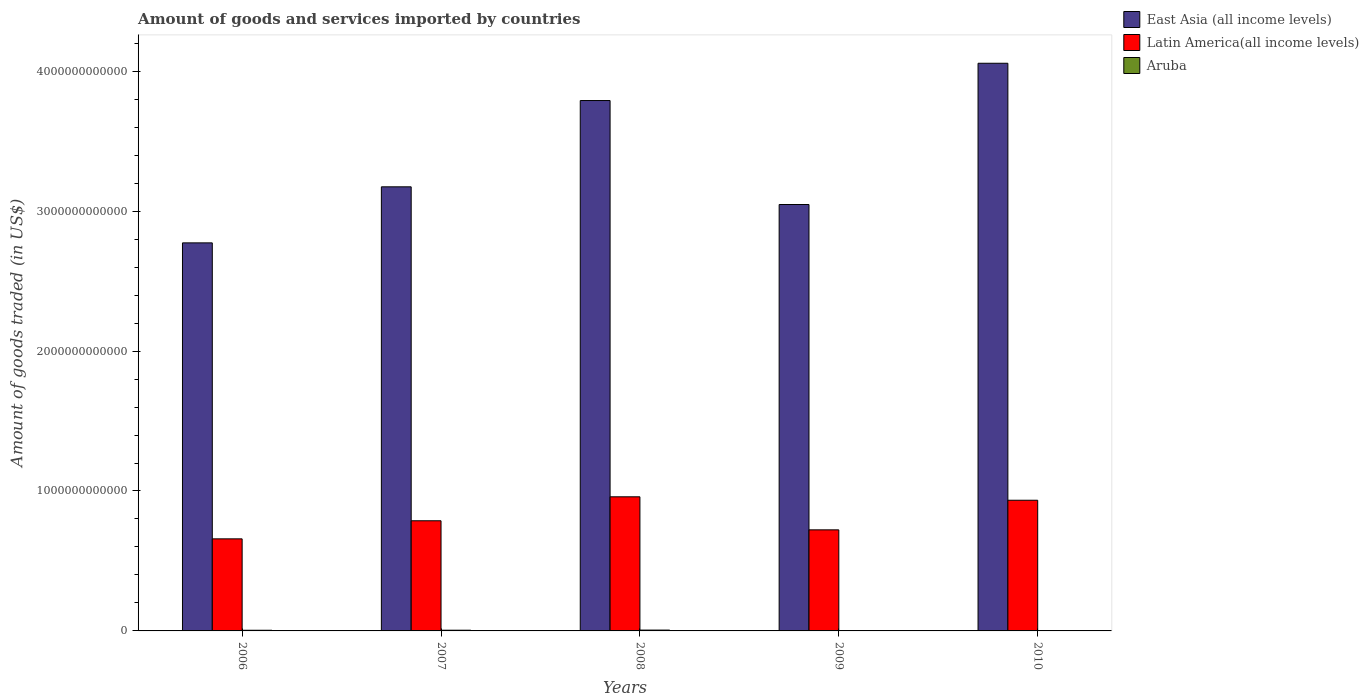How many different coloured bars are there?
Keep it short and to the point. 3. How many groups of bars are there?
Provide a succinct answer. 5. Are the number of bars on each tick of the X-axis equal?
Keep it short and to the point. Yes. How many bars are there on the 1st tick from the left?
Your answer should be compact. 3. How many bars are there on the 2nd tick from the right?
Provide a short and direct response. 3. In how many cases, is the number of bars for a given year not equal to the number of legend labels?
Your response must be concise. 0. What is the total amount of goods and services imported in Latin America(all income levels) in 2007?
Ensure brevity in your answer.  7.87e+11. Across all years, what is the maximum total amount of goods and services imported in East Asia (all income levels)?
Make the answer very short. 4.06e+12. Across all years, what is the minimum total amount of goods and services imported in East Asia (all income levels)?
Your response must be concise. 2.77e+12. In which year was the total amount of goods and services imported in Aruba maximum?
Provide a succinct answer. 2008. What is the total total amount of goods and services imported in Aruba in the graph?
Keep it short and to the point. 1.97e+1. What is the difference between the total amount of goods and services imported in Latin America(all income levels) in 2006 and that in 2009?
Offer a very short reply. -6.43e+1. What is the difference between the total amount of goods and services imported in Aruba in 2009 and the total amount of goods and services imported in East Asia (all income levels) in 2006?
Your response must be concise. -2.77e+12. What is the average total amount of goods and services imported in Aruba per year?
Offer a very short reply. 3.94e+09. In the year 2008, what is the difference between the total amount of goods and services imported in East Asia (all income levels) and total amount of goods and services imported in Latin America(all income levels)?
Ensure brevity in your answer.  2.83e+12. In how many years, is the total amount of goods and services imported in Aruba greater than 2800000000000 US$?
Provide a short and direct response. 0. What is the ratio of the total amount of goods and services imported in East Asia (all income levels) in 2007 to that in 2009?
Offer a terse response. 1.04. Is the total amount of goods and services imported in Latin America(all income levels) in 2006 less than that in 2007?
Provide a short and direct response. Yes. Is the difference between the total amount of goods and services imported in East Asia (all income levels) in 2007 and 2010 greater than the difference between the total amount of goods and services imported in Latin America(all income levels) in 2007 and 2010?
Ensure brevity in your answer.  No. What is the difference between the highest and the second highest total amount of goods and services imported in Latin America(all income levels)?
Make the answer very short. 2.45e+1. What is the difference between the highest and the lowest total amount of goods and services imported in East Asia (all income levels)?
Provide a succinct answer. 1.28e+12. Is the sum of the total amount of goods and services imported in Aruba in 2006 and 2008 greater than the maximum total amount of goods and services imported in East Asia (all income levels) across all years?
Make the answer very short. No. What does the 2nd bar from the left in 2007 represents?
Your answer should be compact. Latin America(all income levels). What does the 1st bar from the right in 2008 represents?
Provide a short and direct response. Aruba. Are all the bars in the graph horizontal?
Provide a succinct answer. No. How many years are there in the graph?
Provide a succinct answer. 5. What is the difference between two consecutive major ticks on the Y-axis?
Provide a succinct answer. 1.00e+12. Does the graph contain grids?
Make the answer very short. No. How many legend labels are there?
Your answer should be very brief. 3. How are the legend labels stacked?
Ensure brevity in your answer.  Vertical. What is the title of the graph?
Offer a terse response. Amount of goods and services imported by countries. What is the label or title of the X-axis?
Your answer should be compact. Years. What is the label or title of the Y-axis?
Provide a succinct answer. Amount of goods traded (in US$). What is the Amount of goods traded (in US$) of East Asia (all income levels) in 2006?
Ensure brevity in your answer.  2.77e+12. What is the Amount of goods traded (in US$) in Latin America(all income levels) in 2006?
Offer a very short reply. 6.58e+11. What is the Amount of goods traded (in US$) of Aruba in 2006?
Provide a succinct answer. 4.72e+09. What is the Amount of goods traded (in US$) in East Asia (all income levels) in 2007?
Make the answer very short. 3.17e+12. What is the Amount of goods traded (in US$) in Latin America(all income levels) in 2007?
Offer a terse response. 7.87e+11. What is the Amount of goods traded (in US$) in Aruba in 2007?
Your answer should be compact. 5.13e+09. What is the Amount of goods traded (in US$) of East Asia (all income levels) in 2008?
Keep it short and to the point. 3.79e+12. What is the Amount of goods traded (in US$) of Latin America(all income levels) in 2008?
Keep it short and to the point. 9.58e+11. What is the Amount of goods traded (in US$) of Aruba in 2008?
Offer a terse response. 6.02e+09. What is the Amount of goods traded (in US$) of East Asia (all income levels) in 2009?
Ensure brevity in your answer.  3.05e+12. What is the Amount of goods traded (in US$) of Latin America(all income levels) in 2009?
Keep it short and to the point. 7.22e+11. What is the Amount of goods traded (in US$) in Aruba in 2009?
Make the answer very short. 2.45e+09. What is the Amount of goods traded (in US$) of East Asia (all income levels) in 2010?
Ensure brevity in your answer.  4.06e+12. What is the Amount of goods traded (in US$) of Latin America(all income levels) in 2010?
Provide a short and direct response. 9.34e+11. What is the Amount of goods traded (in US$) of Aruba in 2010?
Provide a short and direct response. 1.39e+09. Across all years, what is the maximum Amount of goods traded (in US$) in East Asia (all income levels)?
Ensure brevity in your answer.  4.06e+12. Across all years, what is the maximum Amount of goods traded (in US$) of Latin America(all income levels)?
Give a very brief answer. 9.58e+11. Across all years, what is the maximum Amount of goods traded (in US$) in Aruba?
Offer a very short reply. 6.02e+09. Across all years, what is the minimum Amount of goods traded (in US$) in East Asia (all income levels)?
Keep it short and to the point. 2.77e+12. Across all years, what is the minimum Amount of goods traded (in US$) of Latin America(all income levels)?
Keep it short and to the point. 6.58e+11. Across all years, what is the minimum Amount of goods traded (in US$) of Aruba?
Offer a terse response. 1.39e+09. What is the total Amount of goods traded (in US$) in East Asia (all income levels) in the graph?
Ensure brevity in your answer.  1.68e+13. What is the total Amount of goods traded (in US$) of Latin America(all income levels) in the graph?
Keep it short and to the point. 4.06e+12. What is the total Amount of goods traded (in US$) in Aruba in the graph?
Provide a short and direct response. 1.97e+1. What is the difference between the Amount of goods traded (in US$) of East Asia (all income levels) in 2006 and that in 2007?
Provide a short and direct response. -4.01e+11. What is the difference between the Amount of goods traded (in US$) of Latin America(all income levels) in 2006 and that in 2007?
Your answer should be compact. -1.29e+11. What is the difference between the Amount of goods traded (in US$) in Aruba in 2006 and that in 2007?
Provide a succinct answer. -4.02e+08. What is the difference between the Amount of goods traded (in US$) of East Asia (all income levels) in 2006 and that in 2008?
Your answer should be very brief. -1.02e+12. What is the difference between the Amount of goods traded (in US$) of Latin America(all income levels) in 2006 and that in 2008?
Keep it short and to the point. -3.00e+11. What is the difference between the Amount of goods traded (in US$) of Aruba in 2006 and that in 2008?
Your answer should be very brief. -1.29e+09. What is the difference between the Amount of goods traded (in US$) of East Asia (all income levels) in 2006 and that in 2009?
Provide a short and direct response. -2.74e+11. What is the difference between the Amount of goods traded (in US$) in Latin America(all income levels) in 2006 and that in 2009?
Provide a succinct answer. -6.43e+1. What is the difference between the Amount of goods traded (in US$) in Aruba in 2006 and that in 2009?
Offer a terse response. 2.27e+09. What is the difference between the Amount of goods traded (in US$) of East Asia (all income levels) in 2006 and that in 2010?
Keep it short and to the point. -1.28e+12. What is the difference between the Amount of goods traded (in US$) in Latin America(all income levels) in 2006 and that in 2010?
Keep it short and to the point. -2.76e+11. What is the difference between the Amount of goods traded (in US$) of Aruba in 2006 and that in 2010?
Make the answer very short. 3.33e+09. What is the difference between the Amount of goods traded (in US$) of East Asia (all income levels) in 2007 and that in 2008?
Keep it short and to the point. -6.17e+11. What is the difference between the Amount of goods traded (in US$) of Latin America(all income levels) in 2007 and that in 2008?
Offer a very short reply. -1.71e+11. What is the difference between the Amount of goods traded (in US$) in Aruba in 2007 and that in 2008?
Your answer should be compact. -8.92e+08. What is the difference between the Amount of goods traded (in US$) in East Asia (all income levels) in 2007 and that in 2009?
Your answer should be very brief. 1.26e+11. What is the difference between the Amount of goods traded (in US$) in Latin America(all income levels) in 2007 and that in 2009?
Your response must be concise. 6.49e+1. What is the difference between the Amount of goods traded (in US$) of Aruba in 2007 and that in 2009?
Your answer should be very brief. 2.67e+09. What is the difference between the Amount of goods traded (in US$) of East Asia (all income levels) in 2007 and that in 2010?
Provide a short and direct response. -8.83e+11. What is the difference between the Amount of goods traded (in US$) in Latin America(all income levels) in 2007 and that in 2010?
Your answer should be compact. -1.47e+11. What is the difference between the Amount of goods traded (in US$) in Aruba in 2007 and that in 2010?
Give a very brief answer. 3.73e+09. What is the difference between the Amount of goods traded (in US$) of East Asia (all income levels) in 2008 and that in 2009?
Offer a very short reply. 7.43e+11. What is the difference between the Amount of goods traded (in US$) of Latin America(all income levels) in 2008 and that in 2009?
Make the answer very short. 2.36e+11. What is the difference between the Amount of goods traded (in US$) in Aruba in 2008 and that in 2009?
Offer a terse response. 3.56e+09. What is the difference between the Amount of goods traded (in US$) of East Asia (all income levels) in 2008 and that in 2010?
Offer a very short reply. -2.66e+11. What is the difference between the Amount of goods traded (in US$) of Latin America(all income levels) in 2008 and that in 2010?
Ensure brevity in your answer.  2.45e+1. What is the difference between the Amount of goods traded (in US$) in Aruba in 2008 and that in 2010?
Ensure brevity in your answer.  4.62e+09. What is the difference between the Amount of goods traded (in US$) of East Asia (all income levels) in 2009 and that in 2010?
Ensure brevity in your answer.  -1.01e+12. What is the difference between the Amount of goods traded (in US$) of Latin America(all income levels) in 2009 and that in 2010?
Provide a succinct answer. -2.12e+11. What is the difference between the Amount of goods traded (in US$) of Aruba in 2009 and that in 2010?
Provide a short and direct response. 1.06e+09. What is the difference between the Amount of goods traded (in US$) of East Asia (all income levels) in 2006 and the Amount of goods traded (in US$) of Latin America(all income levels) in 2007?
Your response must be concise. 1.99e+12. What is the difference between the Amount of goods traded (in US$) of East Asia (all income levels) in 2006 and the Amount of goods traded (in US$) of Aruba in 2007?
Your answer should be very brief. 2.77e+12. What is the difference between the Amount of goods traded (in US$) of Latin America(all income levels) in 2006 and the Amount of goods traded (in US$) of Aruba in 2007?
Make the answer very short. 6.53e+11. What is the difference between the Amount of goods traded (in US$) of East Asia (all income levels) in 2006 and the Amount of goods traded (in US$) of Latin America(all income levels) in 2008?
Offer a terse response. 1.81e+12. What is the difference between the Amount of goods traded (in US$) of East Asia (all income levels) in 2006 and the Amount of goods traded (in US$) of Aruba in 2008?
Keep it short and to the point. 2.77e+12. What is the difference between the Amount of goods traded (in US$) of Latin America(all income levels) in 2006 and the Amount of goods traded (in US$) of Aruba in 2008?
Provide a short and direct response. 6.52e+11. What is the difference between the Amount of goods traded (in US$) of East Asia (all income levels) in 2006 and the Amount of goods traded (in US$) of Latin America(all income levels) in 2009?
Your response must be concise. 2.05e+12. What is the difference between the Amount of goods traded (in US$) of East Asia (all income levels) in 2006 and the Amount of goods traded (in US$) of Aruba in 2009?
Provide a succinct answer. 2.77e+12. What is the difference between the Amount of goods traded (in US$) in Latin America(all income levels) in 2006 and the Amount of goods traded (in US$) in Aruba in 2009?
Your answer should be compact. 6.56e+11. What is the difference between the Amount of goods traded (in US$) of East Asia (all income levels) in 2006 and the Amount of goods traded (in US$) of Latin America(all income levels) in 2010?
Offer a terse response. 1.84e+12. What is the difference between the Amount of goods traded (in US$) of East Asia (all income levels) in 2006 and the Amount of goods traded (in US$) of Aruba in 2010?
Offer a very short reply. 2.77e+12. What is the difference between the Amount of goods traded (in US$) of Latin America(all income levels) in 2006 and the Amount of goods traded (in US$) of Aruba in 2010?
Offer a very short reply. 6.57e+11. What is the difference between the Amount of goods traded (in US$) in East Asia (all income levels) in 2007 and the Amount of goods traded (in US$) in Latin America(all income levels) in 2008?
Your response must be concise. 2.22e+12. What is the difference between the Amount of goods traded (in US$) in East Asia (all income levels) in 2007 and the Amount of goods traded (in US$) in Aruba in 2008?
Offer a very short reply. 3.17e+12. What is the difference between the Amount of goods traded (in US$) in Latin America(all income levels) in 2007 and the Amount of goods traded (in US$) in Aruba in 2008?
Your response must be concise. 7.81e+11. What is the difference between the Amount of goods traded (in US$) of East Asia (all income levels) in 2007 and the Amount of goods traded (in US$) of Latin America(all income levels) in 2009?
Provide a succinct answer. 2.45e+12. What is the difference between the Amount of goods traded (in US$) of East Asia (all income levels) in 2007 and the Amount of goods traded (in US$) of Aruba in 2009?
Provide a short and direct response. 3.17e+12. What is the difference between the Amount of goods traded (in US$) of Latin America(all income levels) in 2007 and the Amount of goods traded (in US$) of Aruba in 2009?
Your answer should be compact. 7.85e+11. What is the difference between the Amount of goods traded (in US$) of East Asia (all income levels) in 2007 and the Amount of goods traded (in US$) of Latin America(all income levels) in 2010?
Keep it short and to the point. 2.24e+12. What is the difference between the Amount of goods traded (in US$) of East Asia (all income levels) in 2007 and the Amount of goods traded (in US$) of Aruba in 2010?
Make the answer very short. 3.17e+12. What is the difference between the Amount of goods traded (in US$) of Latin America(all income levels) in 2007 and the Amount of goods traded (in US$) of Aruba in 2010?
Your answer should be very brief. 7.86e+11. What is the difference between the Amount of goods traded (in US$) of East Asia (all income levels) in 2008 and the Amount of goods traded (in US$) of Latin America(all income levels) in 2009?
Give a very brief answer. 3.07e+12. What is the difference between the Amount of goods traded (in US$) of East Asia (all income levels) in 2008 and the Amount of goods traded (in US$) of Aruba in 2009?
Keep it short and to the point. 3.79e+12. What is the difference between the Amount of goods traded (in US$) of Latin America(all income levels) in 2008 and the Amount of goods traded (in US$) of Aruba in 2009?
Give a very brief answer. 9.56e+11. What is the difference between the Amount of goods traded (in US$) in East Asia (all income levels) in 2008 and the Amount of goods traded (in US$) in Latin America(all income levels) in 2010?
Make the answer very short. 2.86e+12. What is the difference between the Amount of goods traded (in US$) of East Asia (all income levels) in 2008 and the Amount of goods traded (in US$) of Aruba in 2010?
Keep it short and to the point. 3.79e+12. What is the difference between the Amount of goods traded (in US$) of Latin America(all income levels) in 2008 and the Amount of goods traded (in US$) of Aruba in 2010?
Your response must be concise. 9.57e+11. What is the difference between the Amount of goods traded (in US$) of East Asia (all income levels) in 2009 and the Amount of goods traded (in US$) of Latin America(all income levels) in 2010?
Keep it short and to the point. 2.11e+12. What is the difference between the Amount of goods traded (in US$) of East Asia (all income levels) in 2009 and the Amount of goods traded (in US$) of Aruba in 2010?
Your answer should be compact. 3.05e+12. What is the difference between the Amount of goods traded (in US$) in Latin America(all income levels) in 2009 and the Amount of goods traded (in US$) in Aruba in 2010?
Offer a terse response. 7.21e+11. What is the average Amount of goods traded (in US$) in East Asia (all income levels) per year?
Give a very brief answer. 3.37e+12. What is the average Amount of goods traded (in US$) in Latin America(all income levels) per year?
Your answer should be very brief. 8.12e+11. What is the average Amount of goods traded (in US$) of Aruba per year?
Ensure brevity in your answer.  3.94e+09. In the year 2006, what is the difference between the Amount of goods traded (in US$) of East Asia (all income levels) and Amount of goods traded (in US$) of Latin America(all income levels)?
Keep it short and to the point. 2.12e+12. In the year 2006, what is the difference between the Amount of goods traded (in US$) of East Asia (all income levels) and Amount of goods traded (in US$) of Aruba?
Provide a succinct answer. 2.77e+12. In the year 2006, what is the difference between the Amount of goods traded (in US$) of Latin America(all income levels) and Amount of goods traded (in US$) of Aruba?
Give a very brief answer. 6.53e+11. In the year 2007, what is the difference between the Amount of goods traded (in US$) in East Asia (all income levels) and Amount of goods traded (in US$) in Latin America(all income levels)?
Your answer should be compact. 2.39e+12. In the year 2007, what is the difference between the Amount of goods traded (in US$) of East Asia (all income levels) and Amount of goods traded (in US$) of Aruba?
Provide a short and direct response. 3.17e+12. In the year 2007, what is the difference between the Amount of goods traded (in US$) in Latin America(all income levels) and Amount of goods traded (in US$) in Aruba?
Make the answer very short. 7.82e+11. In the year 2008, what is the difference between the Amount of goods traded (in US$) of East Asia (all income levels) and Amount of goods traded (in US$) of Latin America(all income levels)?
Your answer should be very brief. 2.83e+12. In the year 2008, what is the difference between the Amount of goods traded (in US$) of East Asia (all income levels) and Amount of goods traded (in US$) of Aruba?
Keep it short and to the point. 3.78e+12. In the year 2008, what is the difference between the Amount of goods traded (in US$) in Latin America(all income levels) and Amount of goods traded (in US$) in Aruba?
Your response must be concise. 9.52e+11. In the year 2009, what is the difference between the Amount of goods traded (in US$) in East Asia (all income levels) and Amount of goods traded (in US$) in Latin America(all income levels)?
Your answer should be compact. 2.33e+12. In the year 2009, what is the difference between the Amount of goods traded (in US$) of East Asia (all income levels) and Amount of goods traded (in US$) of Aruba?
Your answer should be very brief. 3.04e+12. In the year 2009, what is the difference between the Amount of goods traded (in US$) in Latin America(all income levels) and Amount of goods traded (in US$) in Aruba?
Provide a short and direct response. 7.20e+11. In the year 2010, what is the difference between the Amount of goods traded (in US$) of East Asia (all income levels) and Amount of goods traded (in US$) of Latin America(all income levels)?
Provide a short and direct response. 3.12e+12. In the year 2010, what is the difference between the Amount of goods traded (in US$) of East Asia (all income levels) and Amount of goods traded (in US$) of Aruba?
Your answer should be compact. 4.06e+12. In the year 2010, what is the difference between the Amount of goods traded (in US$) of Latin America(all income levels) and Amount of goods traded (in US$) of Aruba?
Keep it short and to the point. 9.33e+11. What is the ratio of the Amount of goods traded (in US$) in East Asia (all income levels) in 2006 to that in 2007?
Ensure brevity in your answer.  0.87. What is the ratio of the Amount of goods traded (in US$) in Latin America(all income levels) in 2006 to that in 2007?
Make the answer very short. 0.84. What is the ratio of the Amount of goods traded (in US$) of Aruba in 2006 to that in 2007?
Offer a terse response. 0.92. What is the ratio of the Amount of goods traded (in US$) in East Asia (all income levels) in 2006 to that in 2008?
Your answer should be compact. 0.73. What is the ratio of the Amount of goods traded (in US$) of Latin America(all income levels) in 2006 to that in 2008?
Keep it short and to the point. 0.69. What is the ratio of the Amount of goods traded (in US$) in Aruba in 2006 to that in 2008?
Make the answer very short. 0.79. What is the ratio of the Amount of goods traded (in US$) of East Asia (all income levels) in 2006 to that in 2009?
Keep it short and to the point. 0.91. What is the ratio of the Amount of goods traded (in US$) of Latin America(all income levels) in 2006 to that in 2009?
Your answer should be very brief. 0.91. What is the ratio of the Amount of goods traded (in US$) in Aruba in 2006 to that in 2009?
Provide a short and direct response. 1.93. What is the ratio of the Amount of goods traded (in US$) of East Asia (all income levels) in 2006 to that in 2010?
Ensure brevity in your answer.  0.68. What is the ratio of the Amount of goods traded (in US$) of Latin America(all income levels) in 2006 to that in 2010?
Keep it short and to the point. 0.7. What is the ratio of the Amount of goods traded (in US$) in Aruba in 2006 to that in 2010?
Provide a succinct answer. 3.39. What is the ratio of the Amount of goods traded (in US$) in East Asia (all income levels) in 2007 to that in 2008?
Offer a terse response. 0.84. What is the ratio of the Amount of goods traded (in US$) of Latin America(all income levels) in 2007 to that in 2008?
Give a very brief answer. 0.82. What is the ratio of the Amount of goods traded (in US$) of Aruba in 2007 to that in 2008?
Ensure brevity in your answer.  0.85. What is the ratio of the Amount of goods traded (in US$) in East Asia (all income levels) in 2007 to that in 2009?
Your response must be concise. 1.04. What is the ratio of the Amount of goods traded (in US$) of Latin America(all income levels) in 2007 to that in 2009?
Provide a short and direct response. 1.09. What is the ratio of the Amount of goods traded (in US$) in Aruba in 2007 to that in 2009?
Offer a terse response. 2.09. What is the ratio of the Amount of goods traded (in US$) of East Asia (all income levels) in 2007 to that in 2010?
Give a very brief answer. 0.78. What is the ratio of the Amount of goods traded (in US$) in Latin America(all income levels) in 2007 to that in 2010?
Provide a short and direct response. 0.84. What is the ratio of the Amount of goods traded (in US$) of Aruba in 2007 to that in 2010?
Provide a succinct answer. 3.68. What is the ratio of the Amount of goods traded (in US$) in East Asia (all income levels) in 2008 to that in 2009?
Offer a very short reply. 1.24. What is the ratio of the Amount of goods traded (in US$) of Latin America(all income levels) in 2008 to that in 2009?
Your response must be concise. 1.33. What is the ratio of the Amount of goods traded (in US$) in Aruba in 2008 to that in 2009?
Offer a terse response. 2.45. What is the ratio of the Amount of goods traded (in US$) in East Asia (all income levels) in 2008 to that in 2010?
Offer a terse response. 0.93. What is the ratio of the Amount of goods traded (in US$) in Latin America(all income levels) in 2008 to that in 2010?
Give a very brief answer. 1.03. What is the ratio of the Amount of goods traded (in US$) in Aruba in 2008 to that in 2010?
Your answer should be compact. 4.32. What is the ratio of the Amount of goods traded (in US$) of East Asia (all income levels) in 2009 to that in 2010?
Make the answer very short. 0.75. What is the ratio of the Amount of goods traded (in US$) of Latin America(all income levels) in 2009 to that in 2010?
Give a very brief answer. 0.77. What is the ratio of the Amount of goods traded (in US$) in Aruba in 2009 to that in 2010?
Offer a terse response. 1.76. What is the difference between the highest and the second highest Amount of goods traded (in US$) in East Asia (all income levels)?
Offer a terse response. 2.66e+11. What is the difference between the highest and the second highest Amount of goods traded (in US$) in Latin America(all income levels)?
Your answer should be very brief. 2.45e+1. What is the difference between the highest and the second highest Amount of goods traded (in US$) in Aruba?
Provide a short and direct response. 8.92e+08. What is the difference between the highest and the lowest Amount of goods traded (in US$) of East Asia (all income levels)?
Offer a very short reply. 1.28e+12. What is the difference between the highest and the lowest Amount of goods traded (in US$) of Latin America(all income levels)?
Keep it short and to the point. 3.00e+11. What is the difference between the highest and the lowest Amount of goods traded (in US$) in Aruba?
Your answer should be very brief. 4.62e+09. 